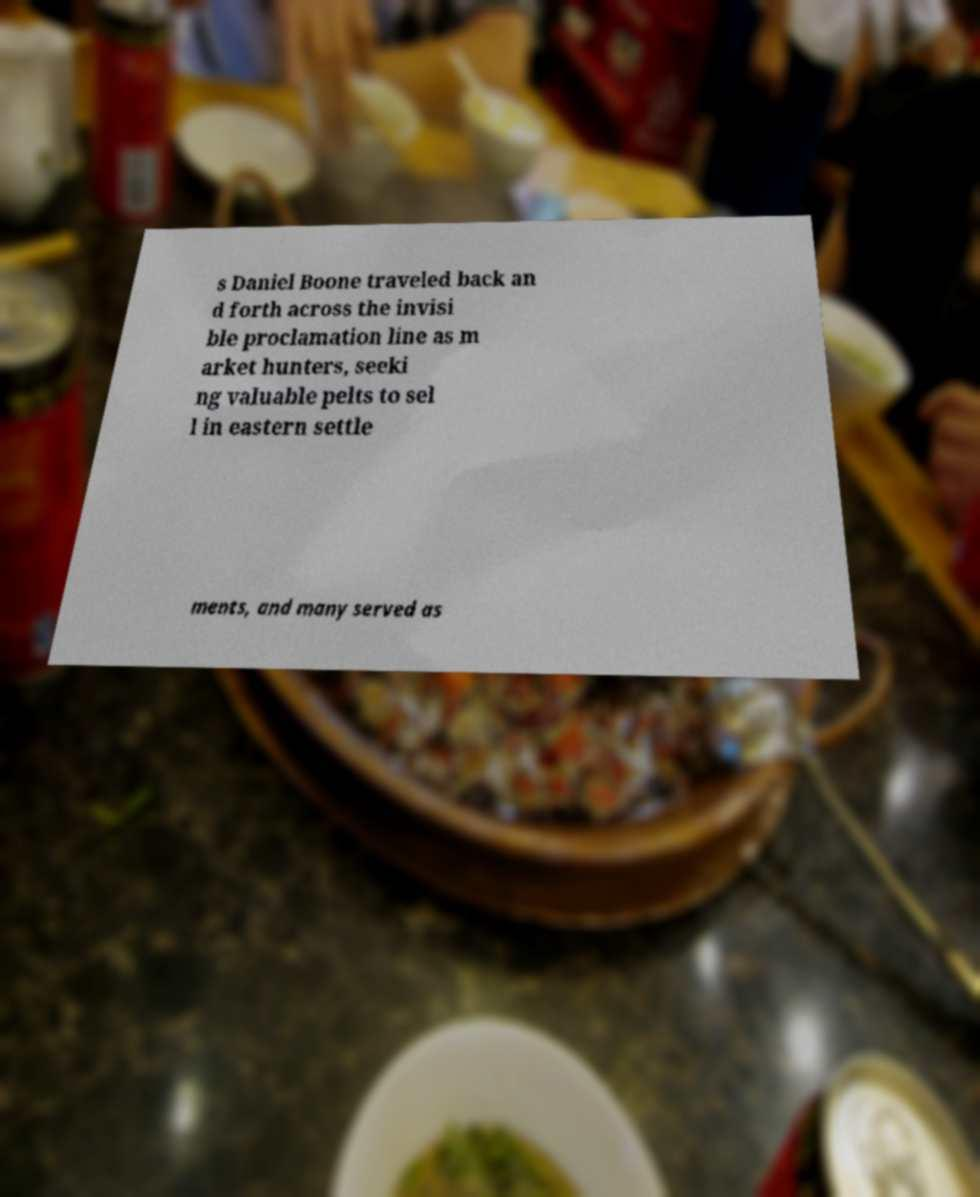Please identify and transcribe the text found in this image. s Daniel Boone traveled back an d forth across the invisi ble proclamation line as m arket hunters, seeki ng valuable pelts to sel l in eastern settle ments, and many served as 